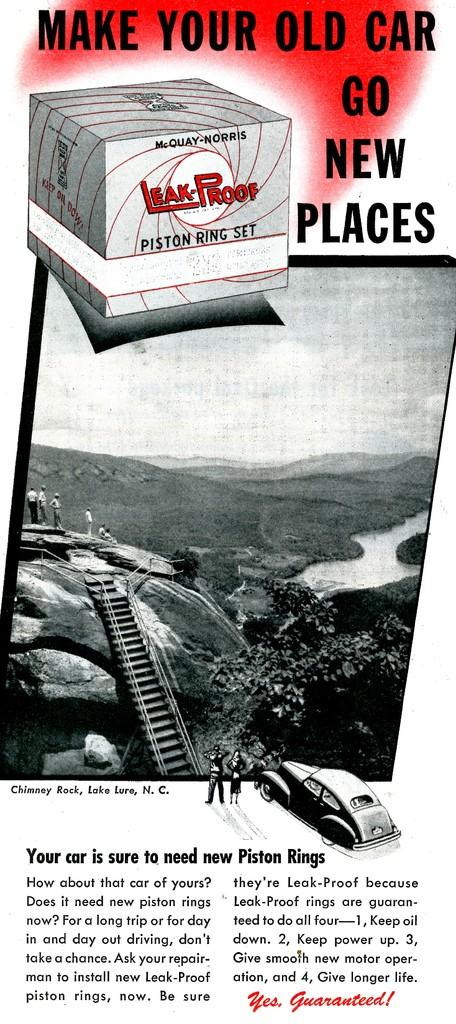<image>
Provide a brief description of the given image. The advertisement is for leak proof piston ring set. 